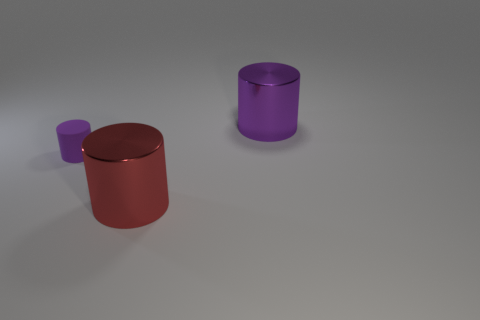Is there any other thing that has the same size as the purple matte cylinder?
Your response must be concise. No. Are there any other things that are made of the same material as the small purple cylinder?
Your answer should be compact. No. What number of objects are either large things to the right of the red thing or purple cylinders?
Offer a very short reply. 2. Is the number of purple matte cylinders that are in front of the tiny thing the same as the number of big red matte balls?
Offer a terse response. Yes. What color is the cylinder that is both right of the rubber cylinder and behind the red metallic cylinder?
Keep it short and to the point. Purple. How many cylinders are large things or purple metallic things?
Make the answer very short. 2. Are there fewer things right of the rubber cylinder than small gray cylinders?
Ensure brevity in your answer.  No. What shape is the large red object that is the same material as the big purple cylinder?
Your answer should be very brief. Cylinder. What number of large cylinders are the same color as the rubber object?
Offer a terse response. 1. What number of objects are either tiny purple rubber objects or small gray cubes?
Your answer should be very brief. 1. 